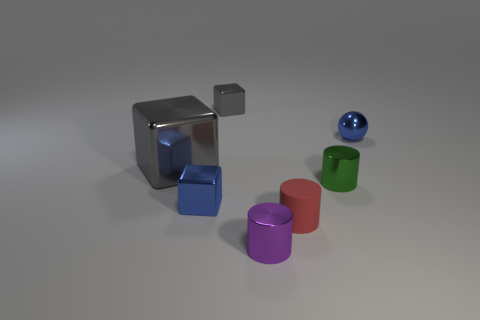Add 1 large blue matte blocks. How many objects exist? 8 Subtract all spheres. How many objects are left? 6 Add 5 tiny red spheres. How many tiny red spheres exist? 5 Subtract 0 brown cylinders. How many objects are left? 7 Subtract all purple metallic cylinders. Subtract all metallic things. How many objects are left? 0 Add 4 red matte objects. How many red matte objects are left? 5 